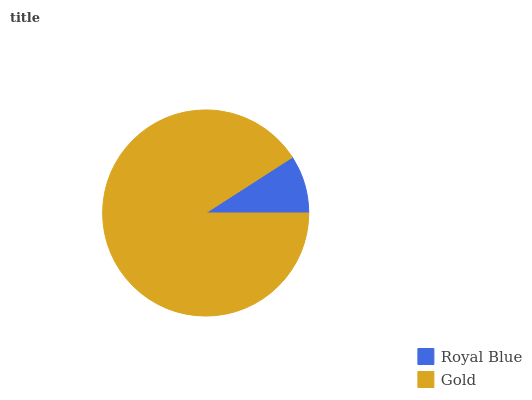Is Royal Blue the minimum?
Answer yes or no. Yes. Is Gold the maximum?
Answer yes or no. Yes. Is Gold the minimum?
Answer yes or no. No. Is Gold greater than Royal Blue?
Answer yes or no. Yes. Is Royal Blue less than Gold?
Answer yes or no. Yes. Is Royal Blue greater than Gold?
Answer yes or no. No. Is Gold less than Royal Blue?
Answer yes or no. No. Is Gold the high median?
Answer yes or no. Yes. Is Royal Blue the low median?
Answer yes or no. Yes. Is Royal Blue the high median?
Answer yes or no. No. Is Gold the low median?
Answer yes or no. No. 